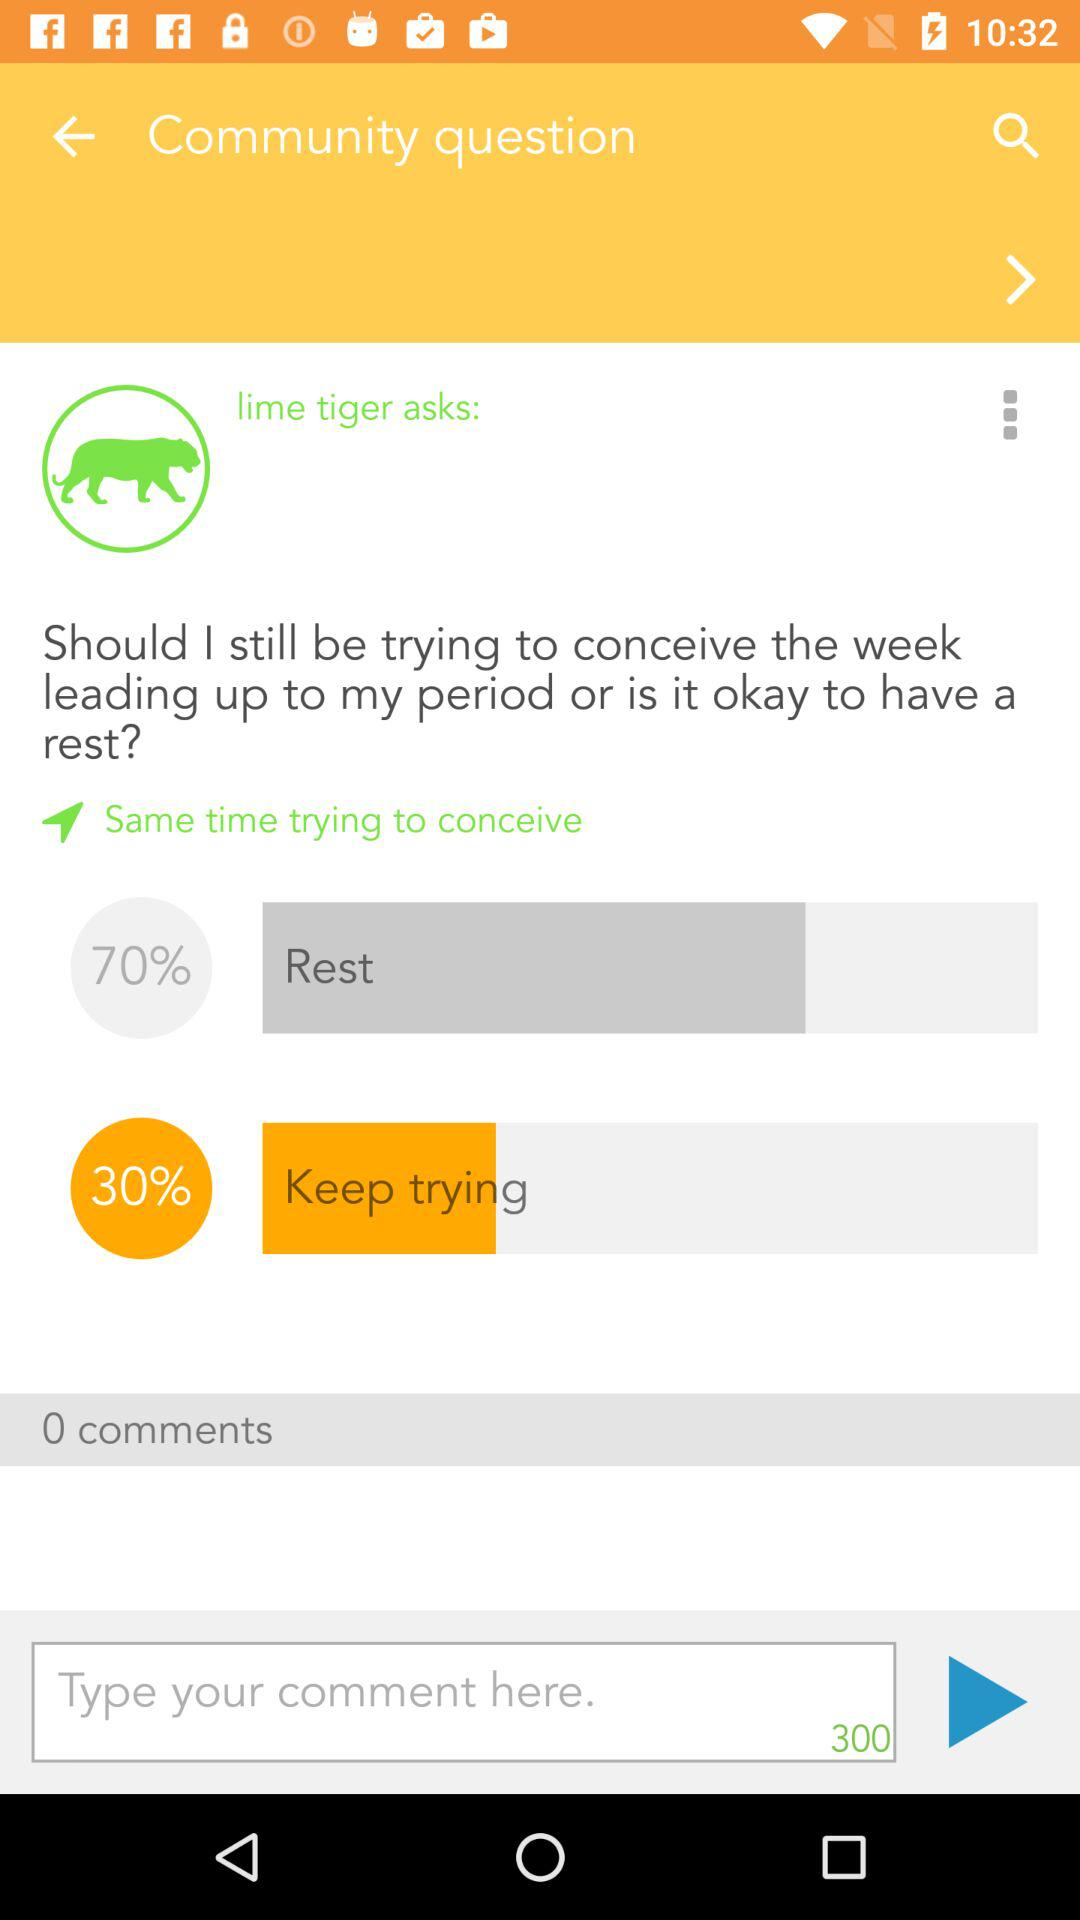What is the Rest percentage?
Answer the question using a single word or phrase. It is 70%. 